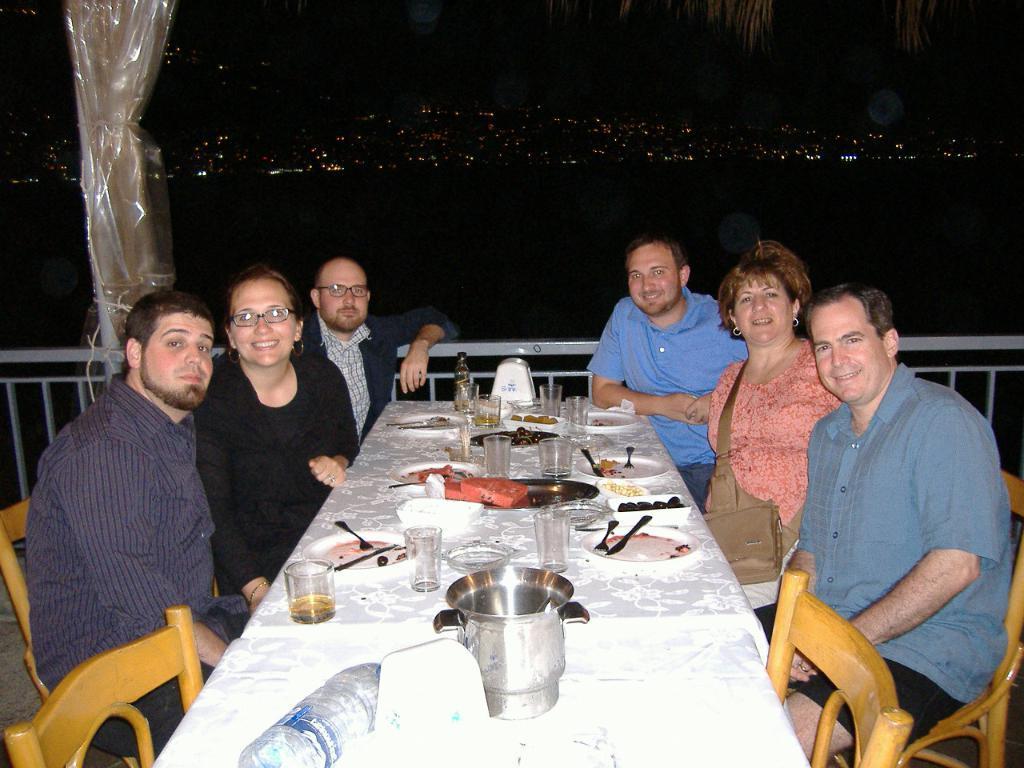Could you give a brief overview of what you see in this image? In the image there are six people two women and four men who are sitting chair behind table. On table we can see a glass,water bottle,jar,plate,spoon,tray and some food. 